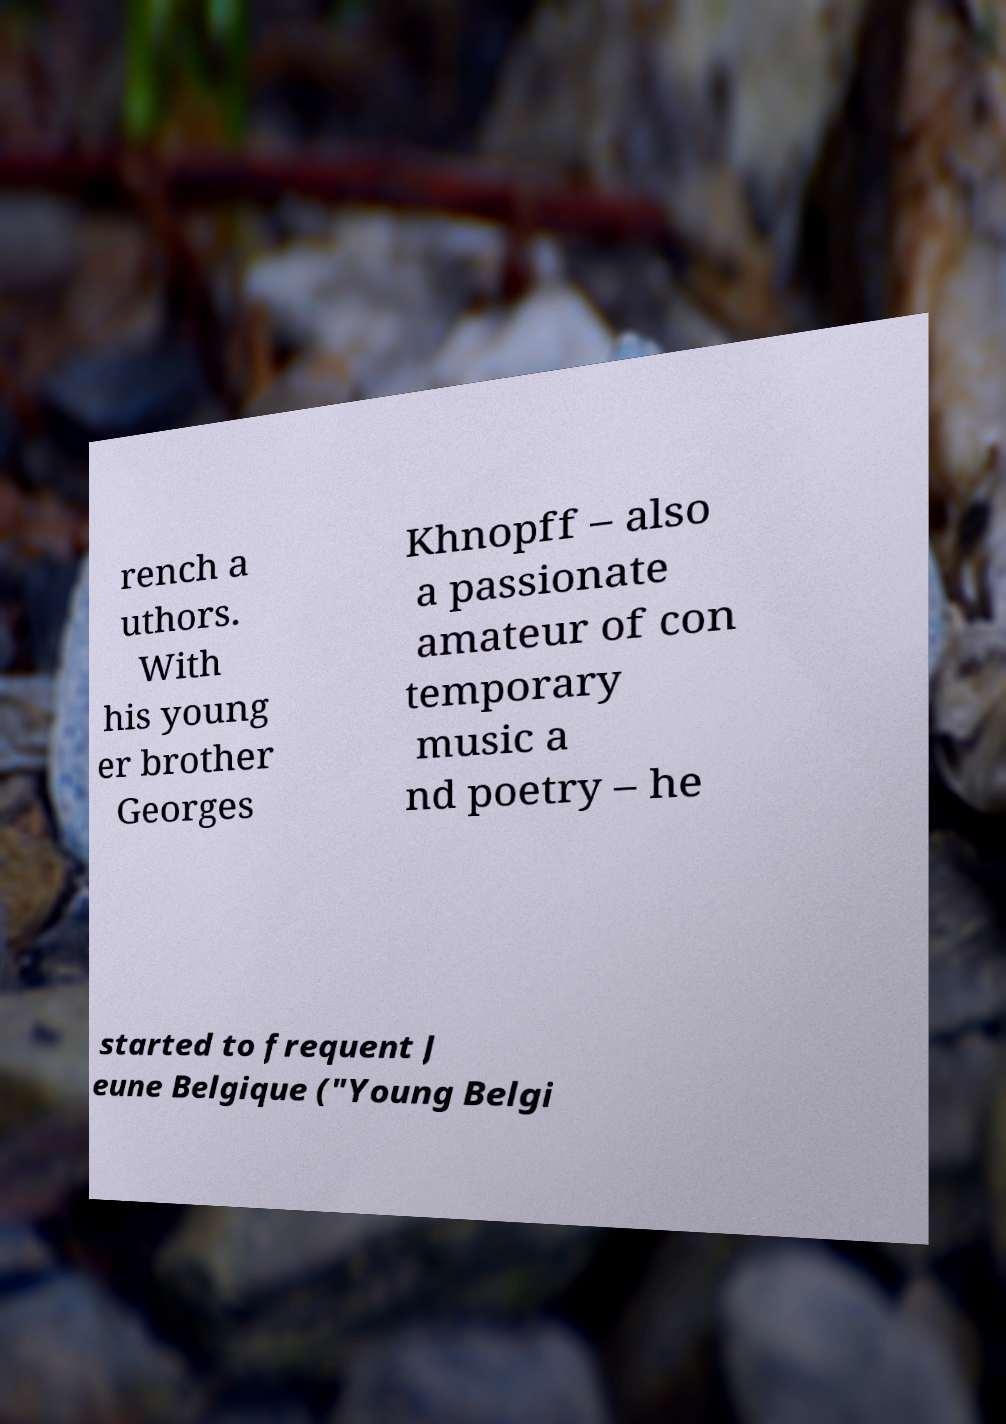What messages or text are displayed in this image? I need them in a readable, typed format. rench a uthors. With his young er brother Georges Khnopff – also a passionate amateur of con temporary music a nd poetry – he started to frequent J eune Belgique ("Young Belgi 